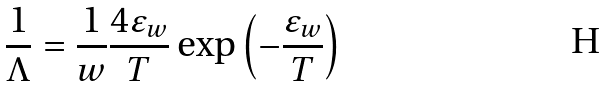Convert formula to latex. <formula><loc_0><loc_0><loc_500><loc_500>\frac { 1 } { \Lambda } = \frac { 1 } { w } \frac { 4 \varepsilon _ { w } } { T } \exp \left ( - \frac { \varepsilon _ { w } } { T } \right )</formula> 